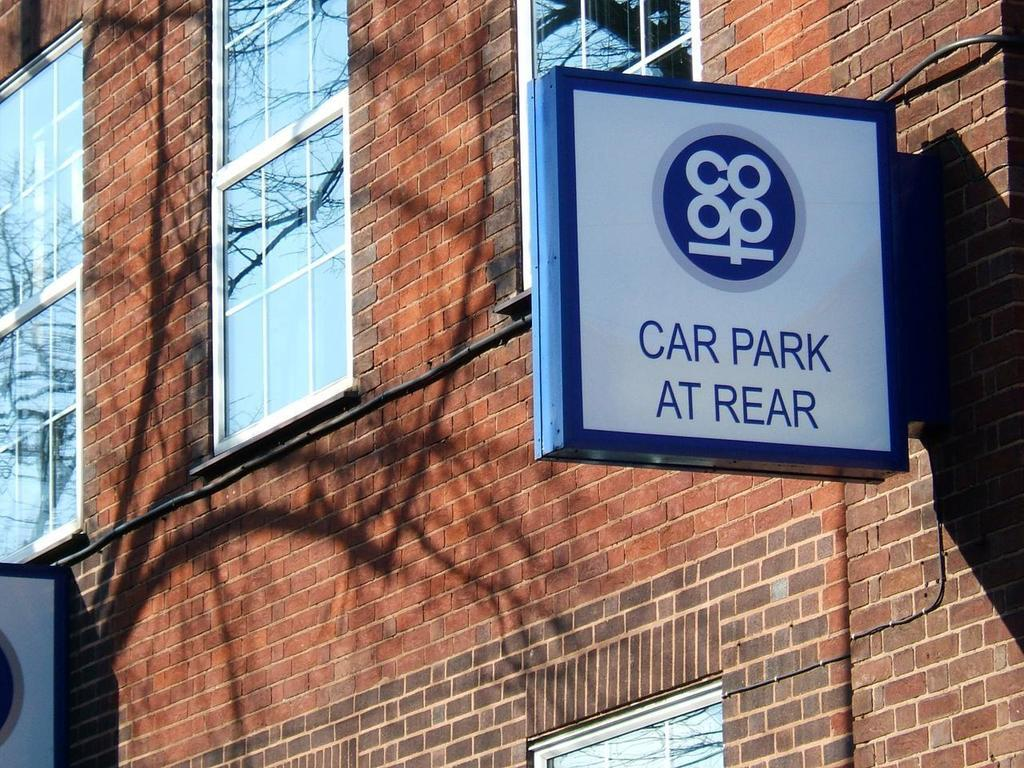What is the main structure visible in the image? There is a wall in the image. What features can be seen on the wall? The wall has windows, posters, and wires. How often does the wall attempt to deliver the news in the image? The wall does not attempt to deliver news, as it is an inanimate object and cannot perform actions or communicate. 